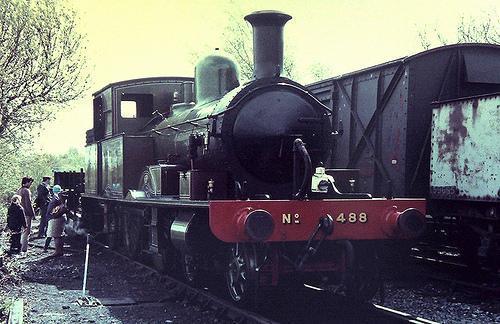How many people are there?
Give a very brief answer. 4. 